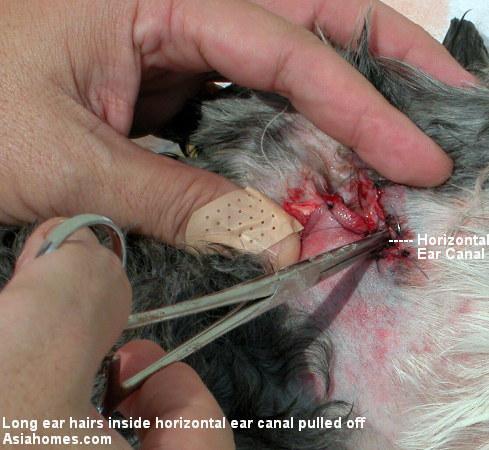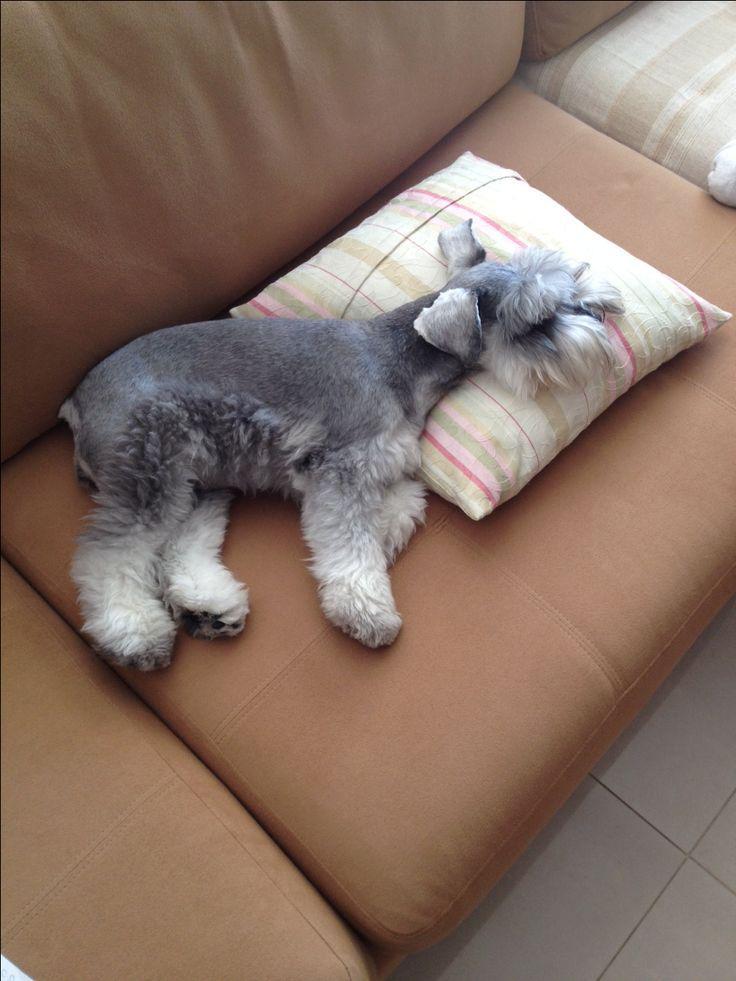The first image is the image on the left, the second image is the image on the right. Evaluate the accuracy of this statement regarding the images: "At least one dog is laying on a couch.". Is it true? Answer yes or no. Yes. The first image is the image on the left, the second image is the image on the right. For the images displayed, is the sentence "At least one dog is looking straight ahead." factually correct? Answer yes or no. No. 